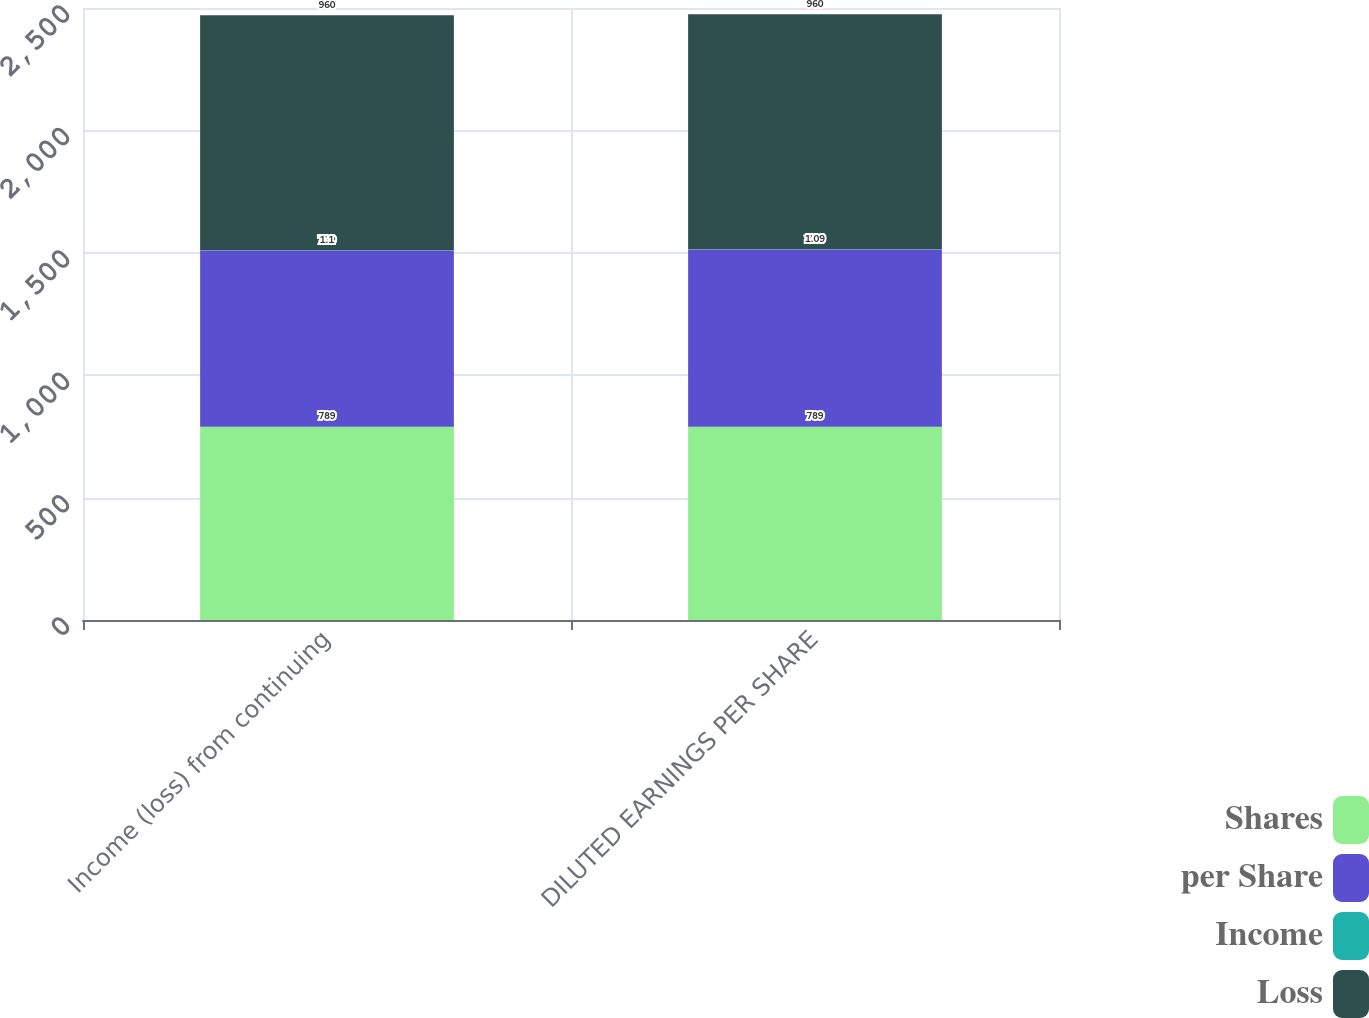Convert chart to OTSL. <chart><loc_0><loc_0><loc_500><loc_500><stacked_bar_chart><ecel><fcel>Income (loss) from continuing<fcel>DILUTED EARNINGS PER SHARE<nl><fcel>Shares<fcel>789<fcel>789<nl><fcel>per Share<fcel>720<fcel>724<nl><fcel>Income<fcel>1.1<fcel>1.09<nl><fcel>Loss<fcel>960<fcel>960<nl></chart> 